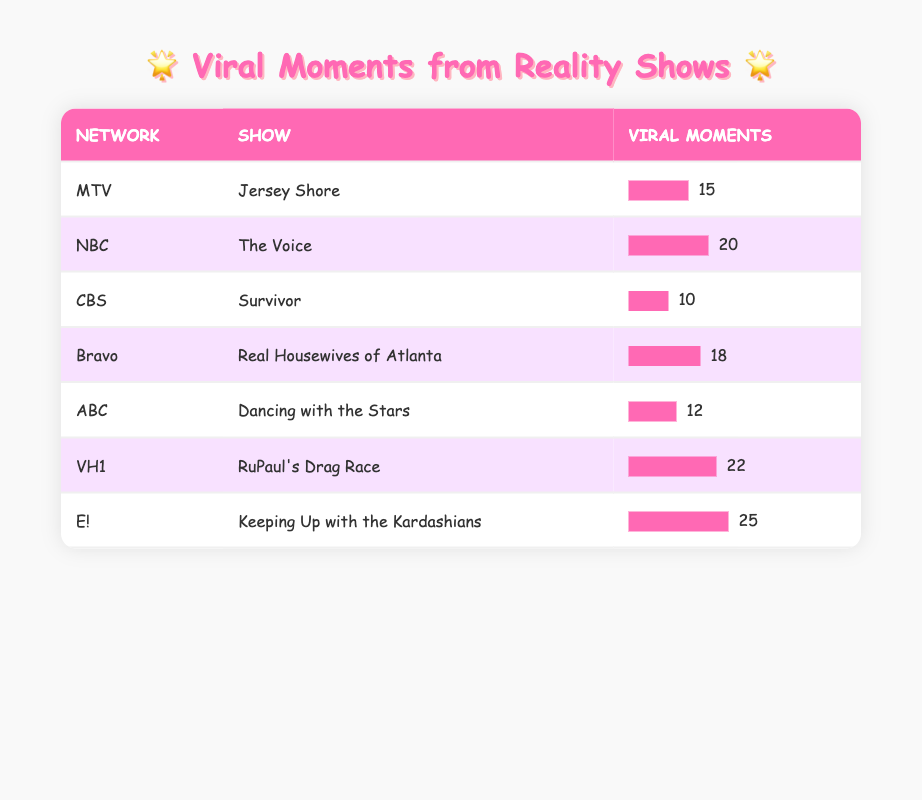What is the number of viral moments for "Keeping Up with the Kardashians"? The table lists "Keeping Up with the Kardashians" under the "E!" network with 25 viral moments.
Answer: 25 Which show has the highest number of viral moments? The table shows that "Keeping Up with the Kardashians" has the highest number of viral moments, totaling 25.
Answer: Keeping Up with the Kardashians How many more viral moments does "The Voice" have than "Survivor"? From the table, "The Voice" has 20 viral moments while "Survivor" has 10. The difference between them is 20 - 10 = 10.
Answer: 10 What is the average number of viral moments across all the shows listed? There are 7 shows with viral moments: 15, 20, 10, 18, 12, 22, and 25. Summing these values gives 15 + 20 + 10 + 18 + 12 + 22 + 25 = 132. The average is 132 / 7 = approximately 18.86.
Answer: 18.86 Is it true that "Real Housewives of Atlanta" has more viral moments than "Dancing with the Stars"? In the table, "Real Housewives of Atlanta" has 18 viral moments while "Dancing with the Stars" has 12. Since 18 is greater than 12, the statement is true.
Answer: Yes How many networks have shows with at least 20 viral moments? By examining the table: "The Voice" (20), "RuPaul's Drag Race" (22), and "Keeping Up with the Kardashians" (25) all have at least 20 viral moments. That means there are 3 networks (NBC, VH1, E!).
Answer: 3 Which network has the least number of viral moments, and what is that number? The table indicates that "Survivor" on the CBS network has the least number of viral moments, which is 10.
Answer: CBS, 10 What is the difference in viral moments between the shows "Jersey Shore" and "RuPaul's Drag Race"? The table shows "Jersey Shore" has 15 viral moments and "RuPaul's Drag Race" has 22. The difference is calculated as 22 - 15 = 7.
Answer: 7 How many total viral moments are represented by the shows on Bravo and MTV combined? The viral moments for "Real Housewives of Atlanta" on Bravo is 18, and "Jersey Shore" on MTV has 15. The total is 18 + 15 = 33.
Answer: 33 